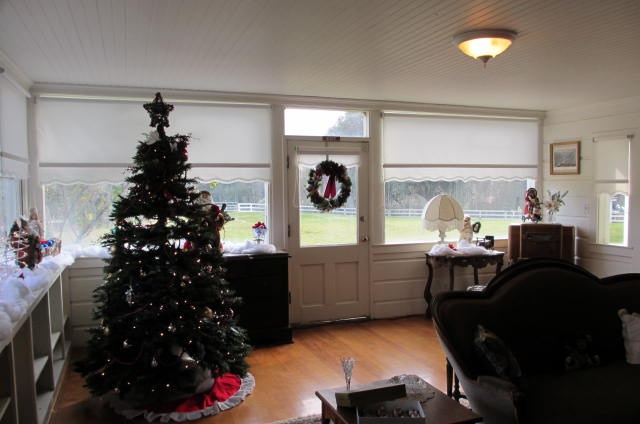Describe the objects in this image and their specific colors. I can see chair in gray and black tones, dining table in gray, black, and darkgray tones, wine glass in gray tones, and vase in gray, darkgray, and lightgray tones in this image. 